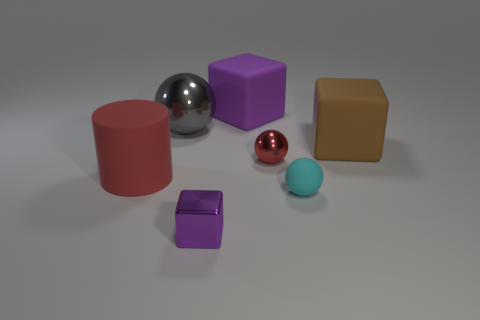Can you describe the lighting and shadows in the image? The lighting in the image is diffuse and seemingly comes from above, casting subtle shadows directly underneath the objects. These shadows are soft-edged, suggesting the light source is not highly focused. 